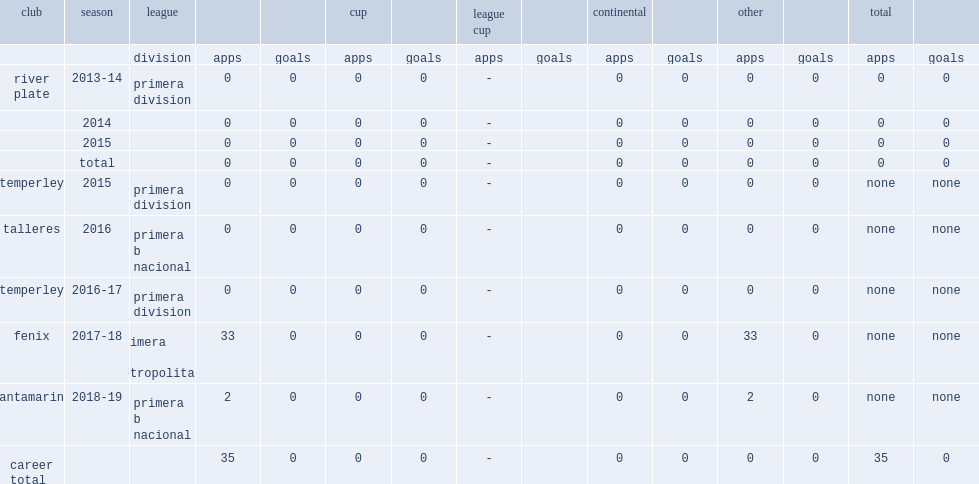Which club did nicolas fabian rodriguez play for in 2016? Talleres. Give me the full table as a dictionary. {'header': ['club', 'season', 'league', '', '', 'cup', '', 'league cup', '', 'continental', '', 'other', '', 'total', ''], 'rows': [['', '', 'division', 'apps', 'goals', 'apps', 'goals', 'apps', 'goals', 'apps', 'goals', 'apps', 'goals', 'apps', 'goals'], ['river plate', '2013-14', 'primera division', '0', '0', '0', '0', '-', '', '0', '0', '0', '0', '0', '0'], ['', '2014', '', '0', '0', '0', '0', '-', '', '0', '0', '0', '0', '0', '0'], ['', '2015', '', '0', '0', '0', '0', '-', '', '0', '0', '0', '0', '0', '0'], ['', 'total', '', '0', '0', '0', '0', '-', '', '0', '0', '0', '0', '0', '0'], ['temperley', '2015', 'primera division', '0', '0', '0', '0', '-', '', '0', '0', '0', '0', 'none', 'none'], ['talleres', '2016', 'primera b nacional', '0', '0', '0', '0', '-', '', '0', '0', '0', '0', 'none', 'none'], ['temperley', '2016-17', 'primera division', '0', '0', '0', '0', '-', '', '0', '0', '0', '0', 'none', 'none'], ['fenix', '2017-18', 'primera b metropolitana', '33', '0', '0', '0', '-', '', '0', '0', '33', '0', 'none', 'none'], ['santamarina', '2018-19', 'primera b nacional', '2', '0', '0', '0', '-', '', '0', '0', '2', '0', 'none', 'none'], ['career total', '', '', '35', '0', '0', '0', '-', '', '0', '0', '0', '0', '35', '0']]} 